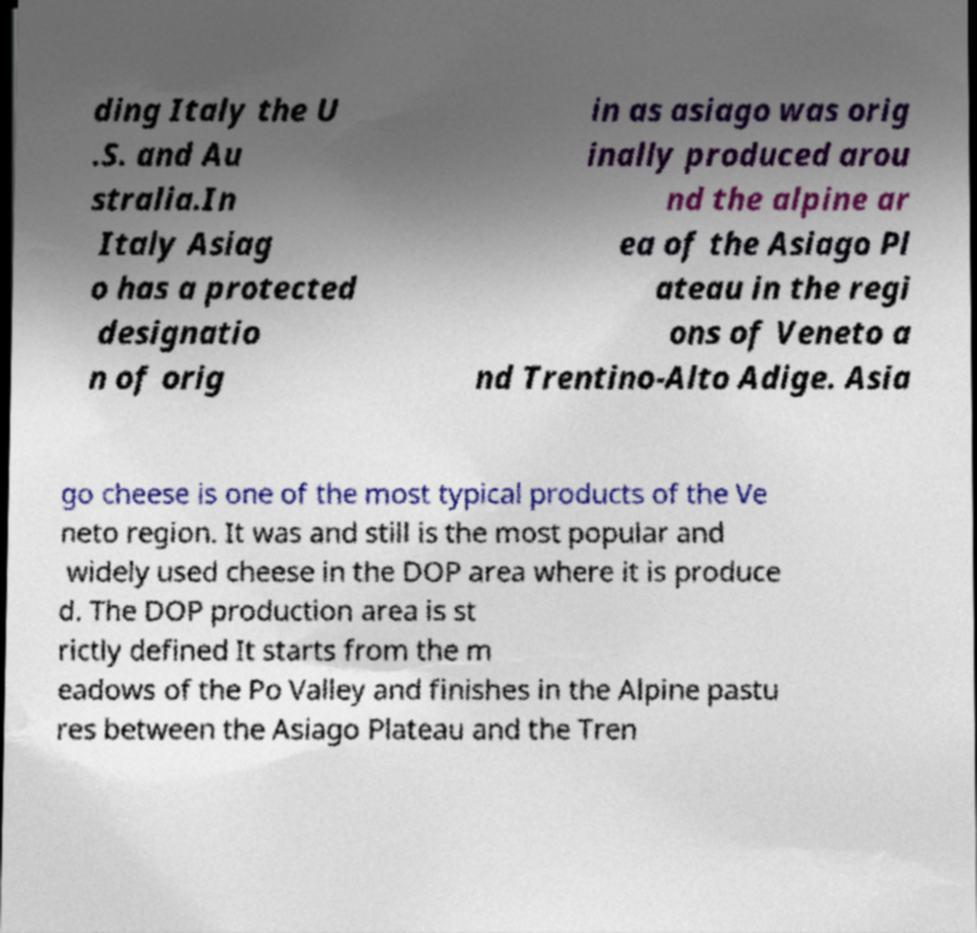There's text embedded in this image that I need extracted. Can you transcribe it verbatim? ding Italy the U .S. and Au stralia.In Italy Asiag o has a protected designatio n of orig in as asiago was orig inally produced arou nd the alpine ar ea of the Asiago Pl ateau in the regi ons of Veneto a nd Trentino-Alto Adige. Asia go cheese is one of the most typical products of the Ve neto region. It was and still is the most popular and widely used cheese in the DOP area where it is produce d. The DOP production area is st rictly defined It starts from the m eadows of the Po Valley and finishes in the Alpine pastu res between the Asiago Plateau and the Tren 